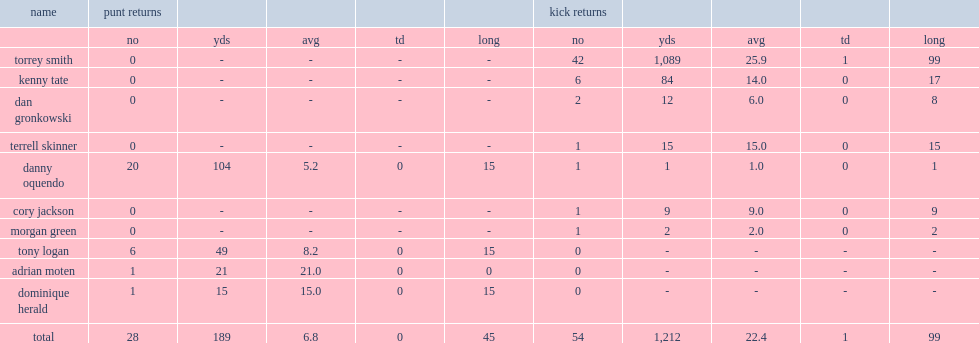How many kickoff yards did maryland's torrey smith have? 1089.0. 